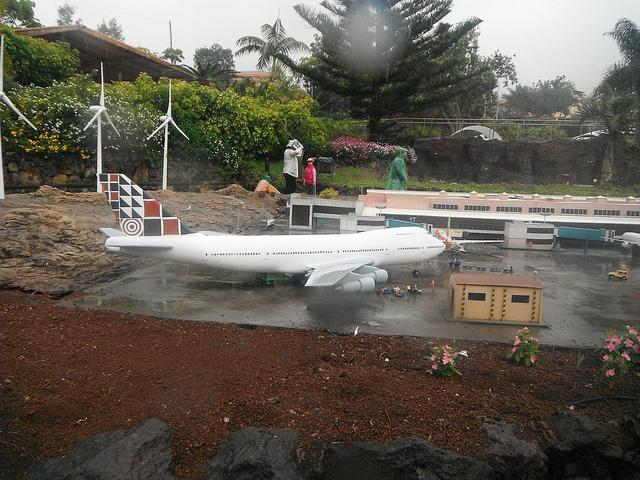What is this place? Please explain your reasoning. amusement park. The place is an amusement park. 